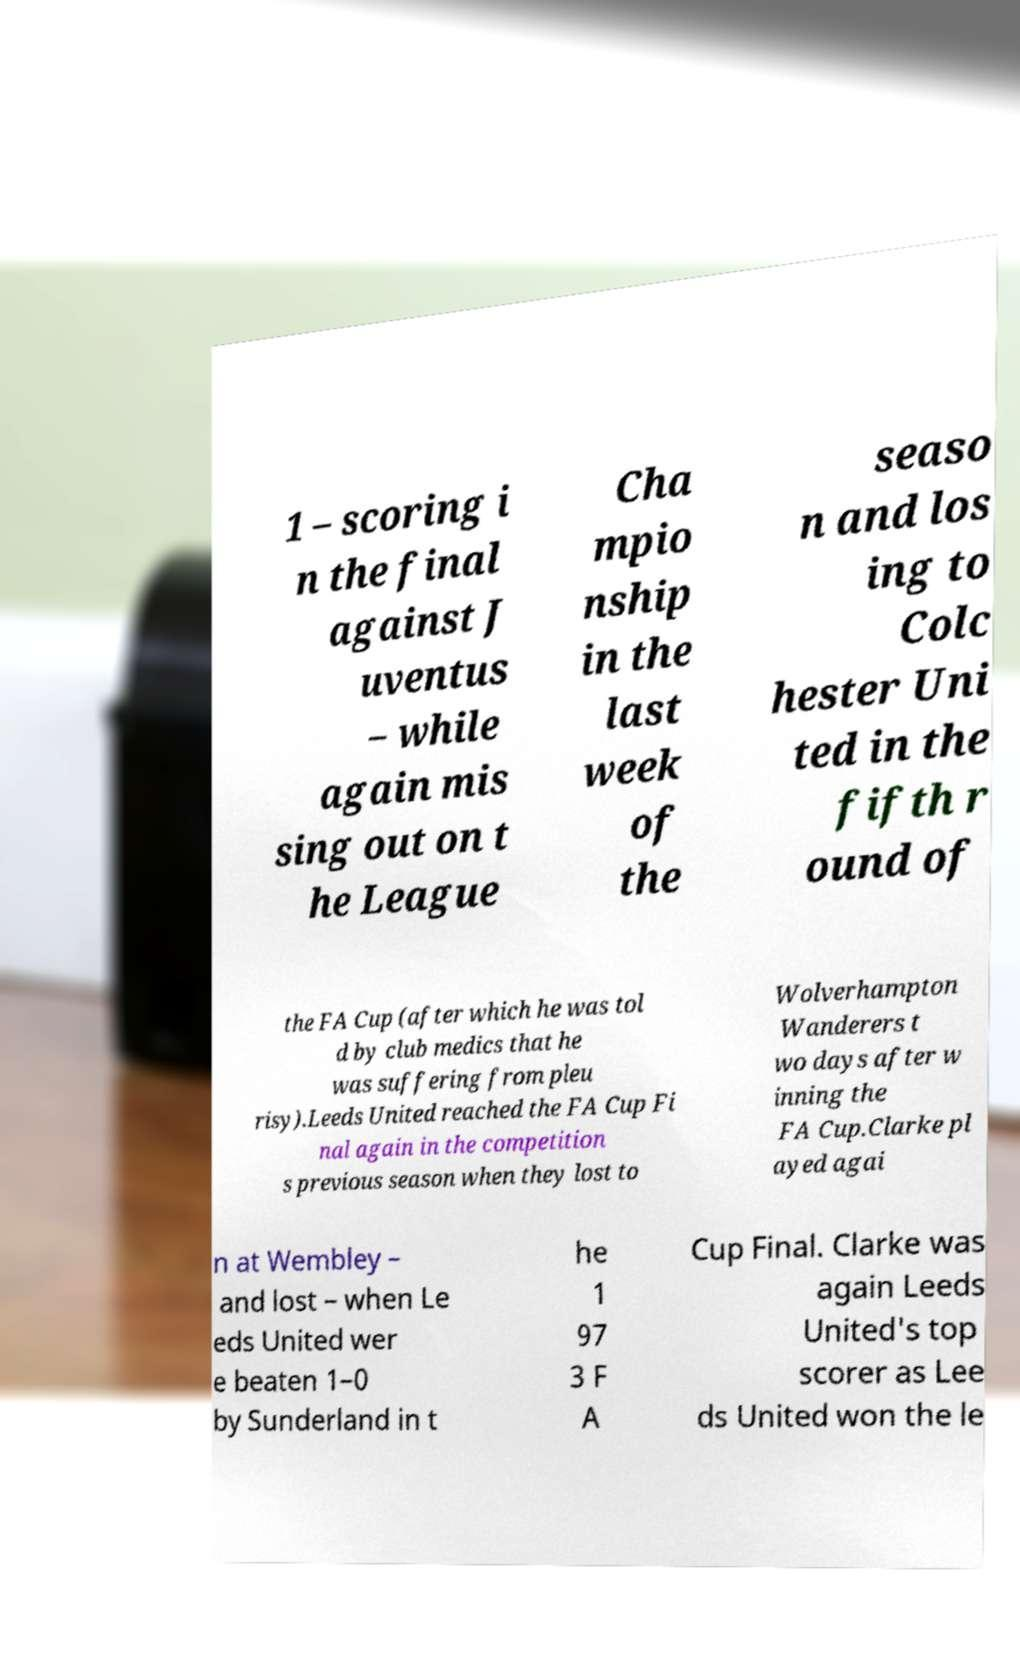For documentation purposes, I need the text within this image transcribed. Could you provide that? 1 – scoring i n the final against J uventus – while again mis sing out on t he League Cha mpio nship in the last week of the seaso n and los ing to Colc hester Uni ted in the fifth r ound of the FA Cup (after which he was tol d by club medics that he was suffering from pleu risy).Leeds United reached the FA Cup Fi nal again in the competition s previous season when they lost to Wolverhampton Wanderers t wo days after w inning the FA Cup.Clarke pl ayed agai n at Wembley – and lost – when Le eds United wer e beaten 1–0 by Sunderland in t he 1 97 3 F A Cup Final. Clarke was again Leeds United's top scorer as Lee ds United won the le 